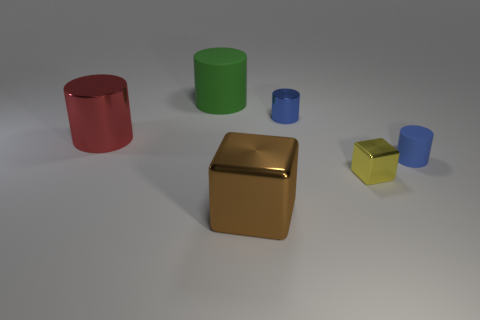Subtract all big green cylinders. How many cylinders are left? 3 Add 4 blue things. How many objects exist? 10 Subtract all blue cylinders. How many cylinders are left? 2 Subtract all blocks. How many objects are left? 4 Subtract 2 cubes. How many cubes are left? 0 Subtract all gray cylinders. How many yellow cubes are left? 1 Subtract all red objects. Subtract all large blocks. How many objects are left? 4 Add 2 small metallic objects. How many small metallic objects are left? 4 Add 1 yellow metal cubes. How many yellow metal cubes exist? 2 Subtract 0 gray cylinders. How many objects are left? 6 